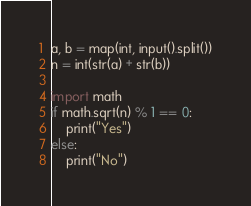<code> <loc_0><loc_0><loc_500><loc_500><_Python_>a, b = map(int, input().split())
n = int(str(a) + str(b))

import math
if math.sqrt(n) % 1 == 0:
    print("Yes")
else:
    print("No")</code> 